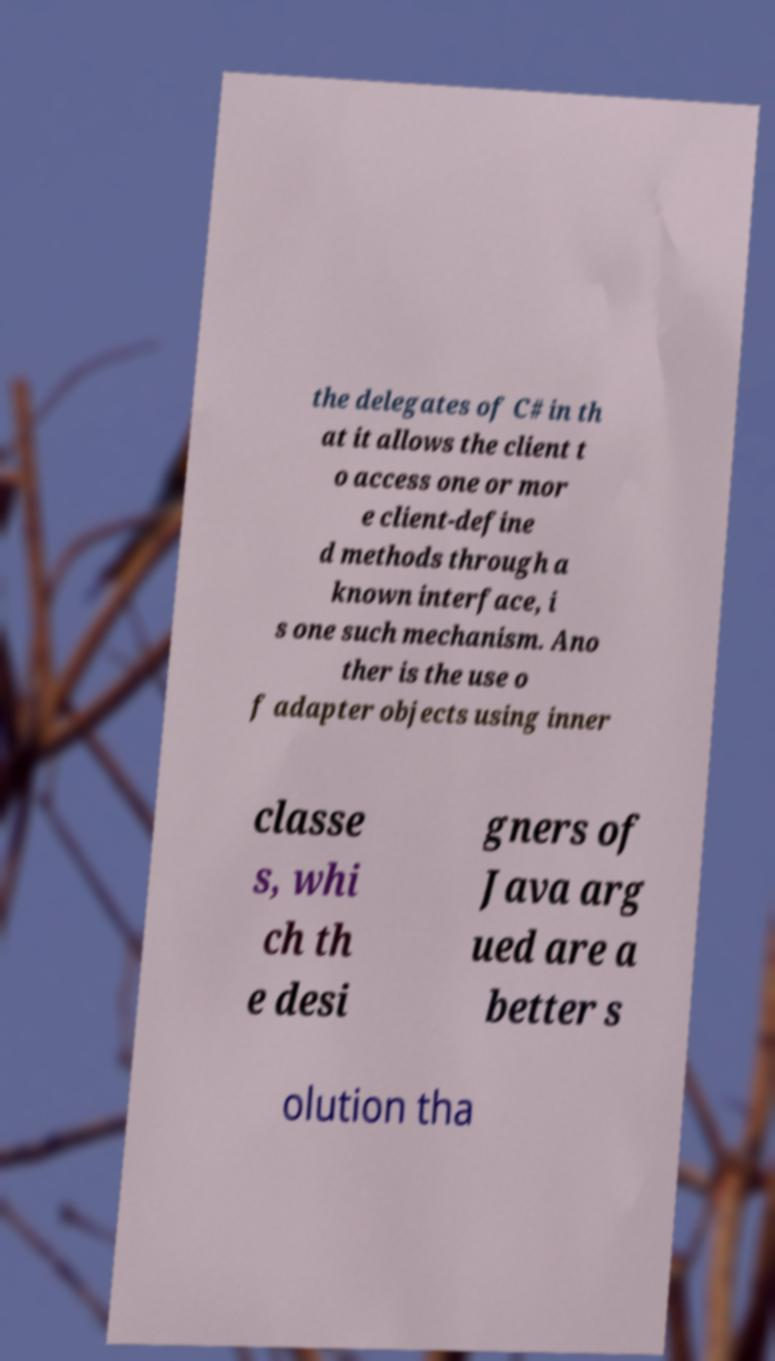Can you read and provide the text displayed in the image?This photo seems to have some interesting text. Can you extract and type it out for me? the delegates of C# in th at it allows the client t o access one or mor e client-define d methods through a known interface, i s one such mechanism. Ano ther is the use o f adapter objects using inner classe s, whi ch th e desi gners of Java arg ued are a better s olution tha 